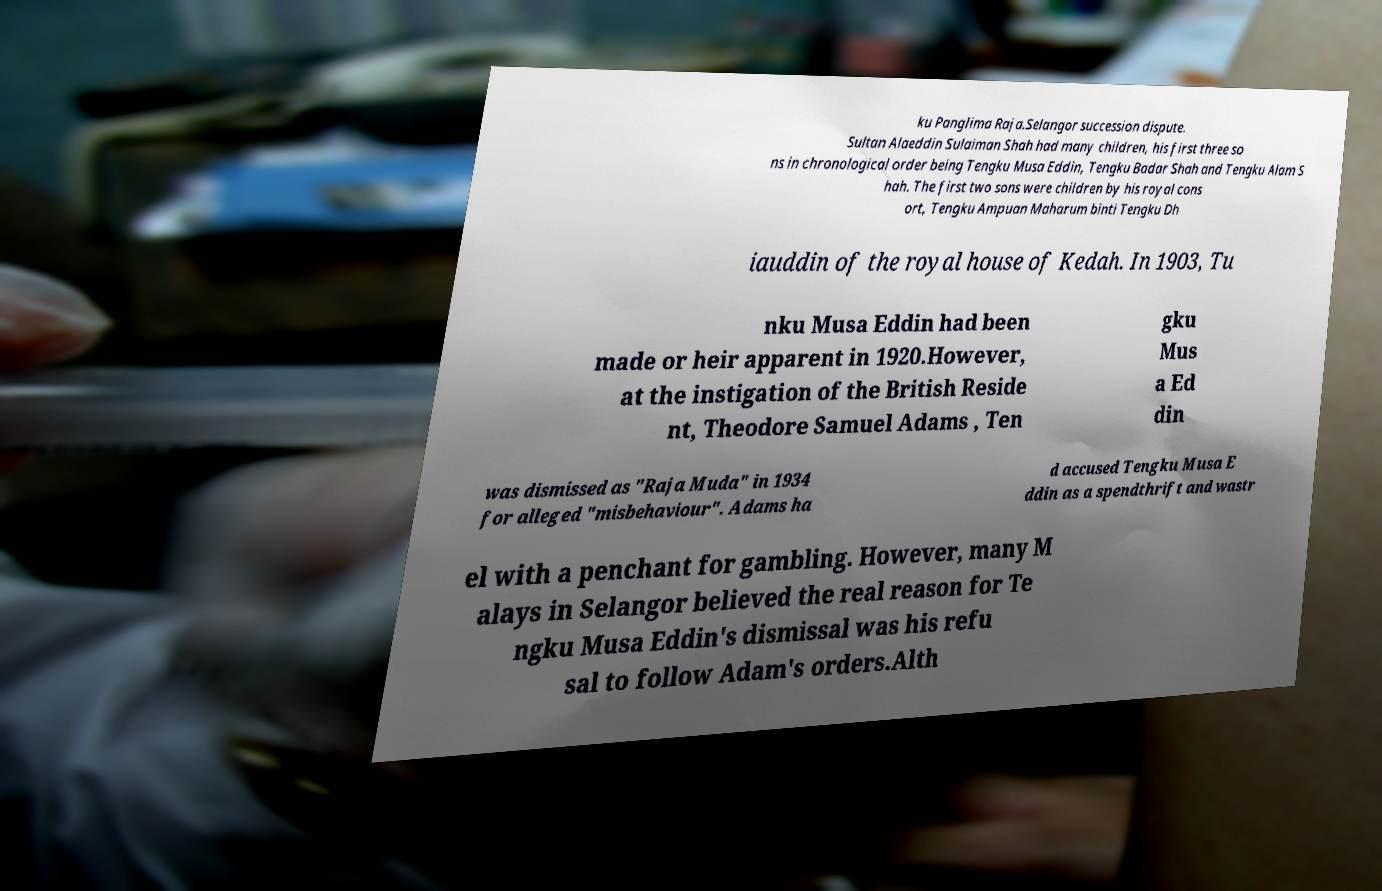There's text embedded in this image that I need extracted. Can you transcribe it verbatim? ku Panglima Raja.Selangor succession dispute. Sultan Alaeddin Sulaiman Shah had many children, his first three so ns in chronological order being Tengku Musa Eddin, Tengku Badar Shah and Tengku Alam S hah. The first two sons were children by his royal cons ort, Tengku Ampuan Maharum binti Tengku Dh iauddin of the royal house of Kedah. In 1903, Tu nku Musa Eddin had been made or heir apparent in 1920.However, at the instigation of the British Reside nt, Theodore Samuel Adams , Ten gku Mus a Ed din was dismissed as "Raja Muda" in 1934 for alleged "misbehaviour". Adams ha d accused Tengku Musa E ddin as a spendthrift and wastr el with a penchant for gambling. However, many M alays in Selangor believed the real reason for Te ngku Musa Eddin's dismissal was his refu sal to follow Adam's orders.Alth 